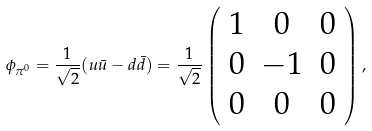<formula> <loc_0><loc_0><loc_500><loc_500>\ \phi _ { \pi ^ { 0 } } = \frac { 1 } { \sqrt { 2 } } ( u \bar { u } - d \bar { d } ) = \frac { 1 } { \sqrt { 2 } } \left ( \begin{array} { c c c } 1 & 0 & 0 \\ 0 & - 1 & 0 \\ 0 & 0 & 0 \end{array} \right ) ,</formula> 